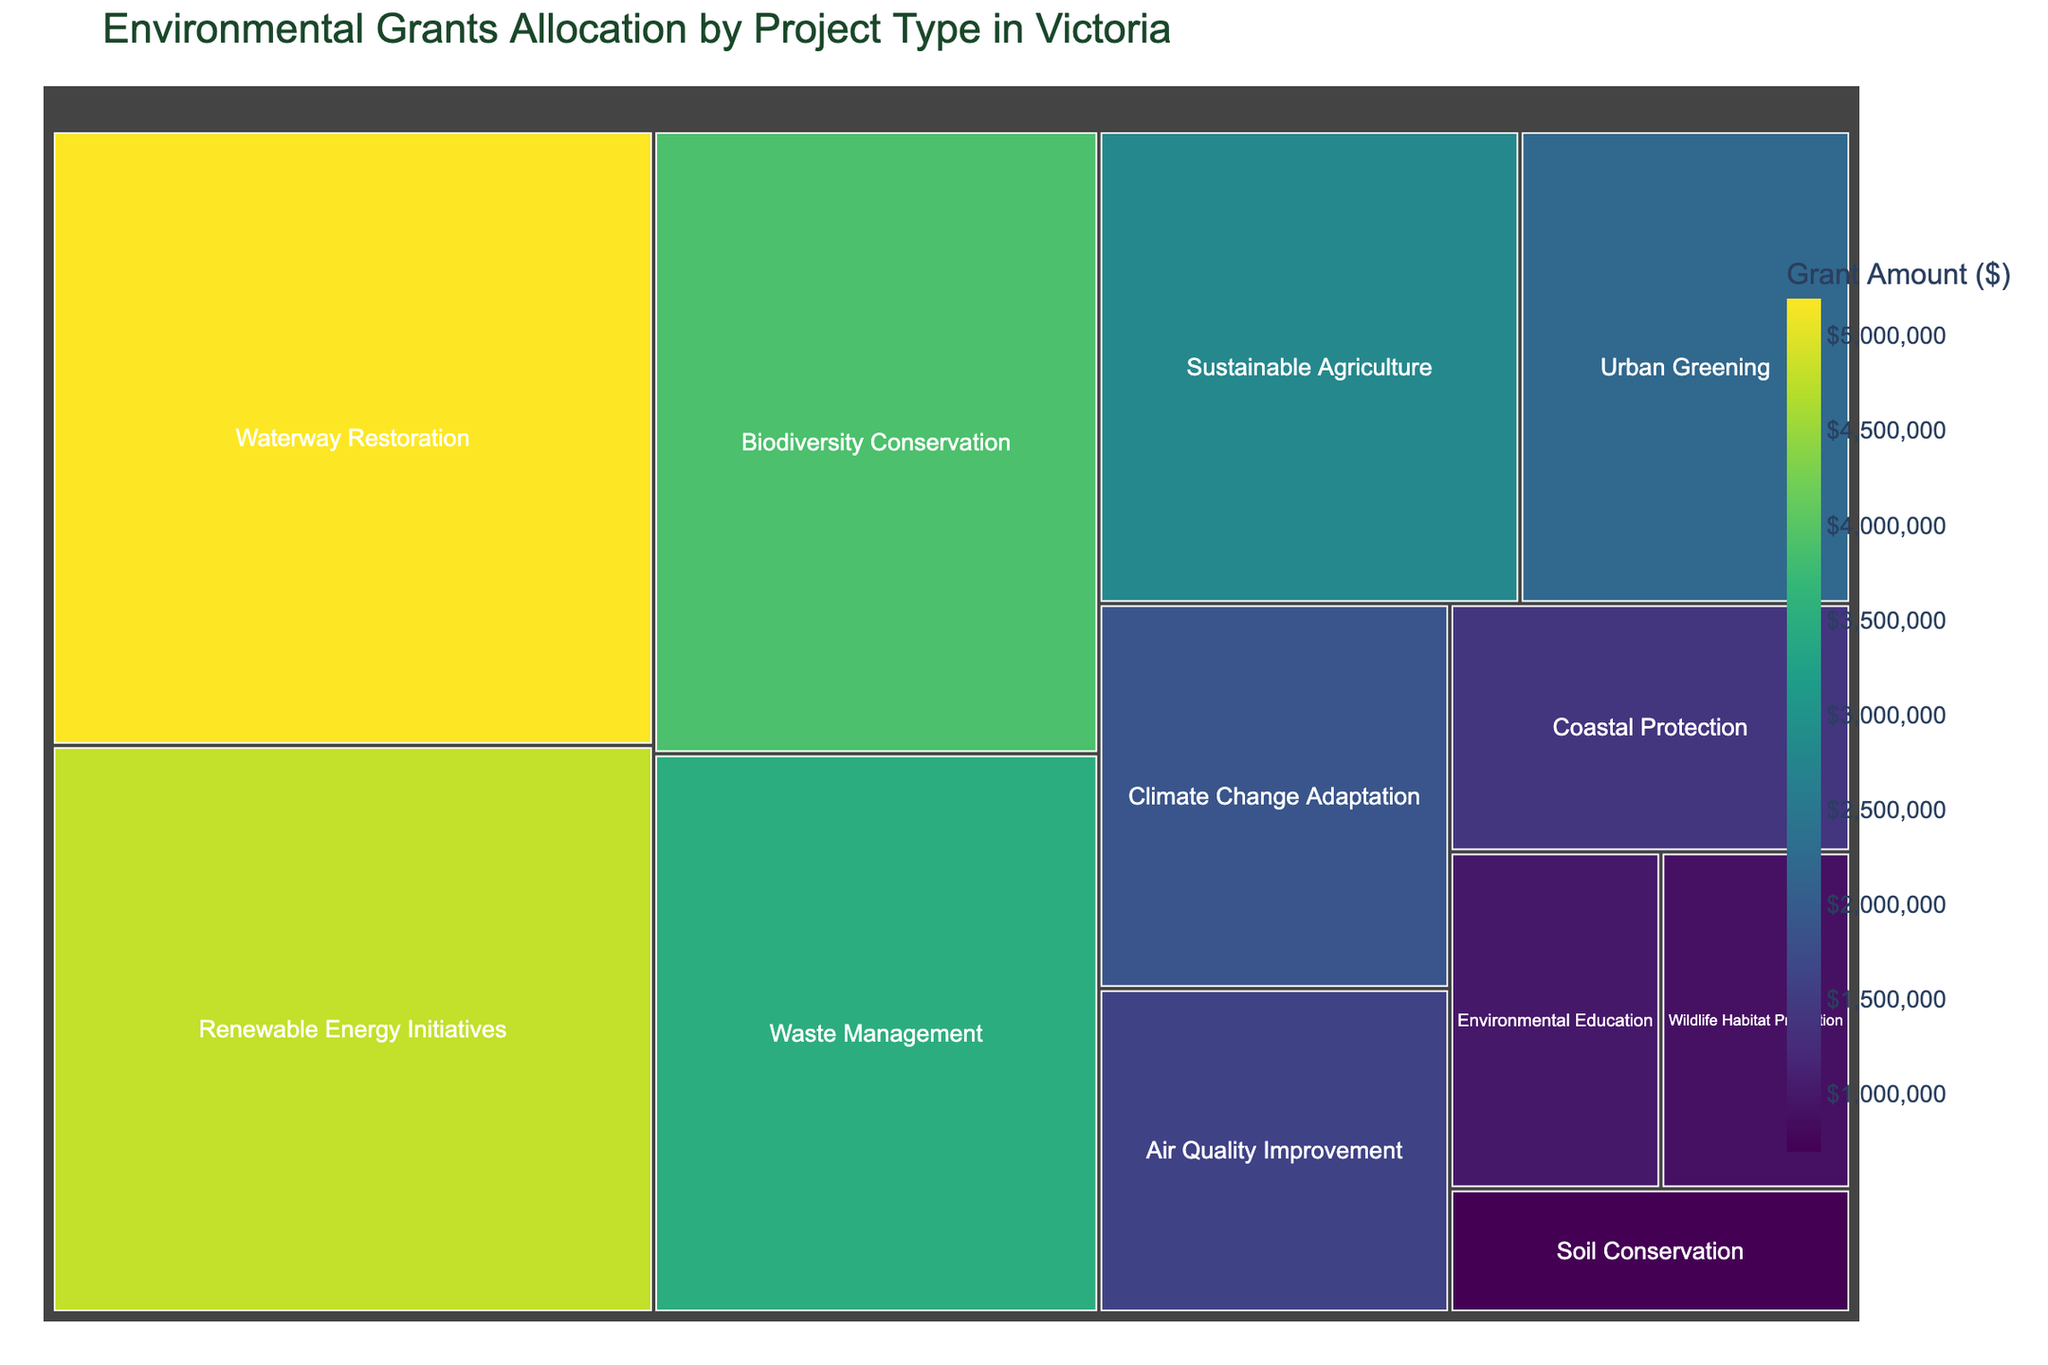What is the title of the treemap? The title of the treemap is displayed at the top of the figure, providing a description of what the treemap represents.
Answer: Environmental Grants Allocation by Project Type in Victoria Which project type received the highest grant amount? The largest block in the treemap, which also has the highest grant amount, represents the project type with the highest funding.
Answer: Waterway Restoration How much grant amount was allocated to Renewable Energy Initiatives? Find the block labeled "Renewable Energy Initiatives" in the treemap, and observe the grant amount displayed on it.
Answer: $4,800,000 What is the total grant amount allocated to both Waste Management and Air Quality Improvement? Look at the grant amounts for Waste Management and Air Quality Improvement blocks, then add them together: $3,500,000 + $1,600,000.
Answer: $5,100,000 Which project type received a smaller grant amount: Coastal Protection or Wildlife Habitat Protection? Compare the grant amounts of the blocks labeled "Coastal Protection" and "Wildlife Habitat Protection." Coastal Protection received $1,400,000, whereas Wildlife Habitat Protection got $900,000.
Answer: Wildlife Habitat Protection What is the combined grant amount for all project types that received more than $3,000,000? Identify project types with grant amounts exceeding $3,000,000: Waterway Restoration, Renewable Energy Initiatives, Biodiversity Conservation, and Waste Management. Sum their amounts: $5,200,000 + $4,800,000 + $3,900,000 + $3,500,000.
Answer: $17,400,000 Which project type received the lowest grant amount? Find the smallest block in the treemap, which represents the project type with the lowest grant amount.
Answer: Soil Conservation Is the grant amount allocated to Climate Change Adaptation higher or lower than that for Sustainable Agriculture? Compare the grant amounts for the blocks labeled "Climate Change Adaptation" and "Sustainable Agriculture." Climate Change Adaptation received $1,900,000, while Sustainable Agriculture got $2,800,000.
Answer: Lower What is the difference in grant amounts between Urban Greening and Air Quality Improvement? Look at the grant amounts for Urban Greening and Air Quality Improvement blocks, and subtract the smaller amount from the larger one: $2,200,000 - $1,600,000.
Answer: $600,000 Which project types received more funding than Environmental Education? Identify the blocks with grant amounts higher than the Environmental Education block, which received $1,000,000. These higher amounts belong to Waterway Restoration, Renewable Energy Initiatives, Biodiversity Conservation, Waste Management, Sustainable Agriculture, Urban Greening, Climate Change Adaptation, and Air Quality Improvement.
Answer: Waterway Restoration, Renewable Energy Initiatives, Biodiversity Conservation, Waste Management, Sustainable Agriculture, Urban Greening, Climate Change Adaptation, Air Quality Improvement 